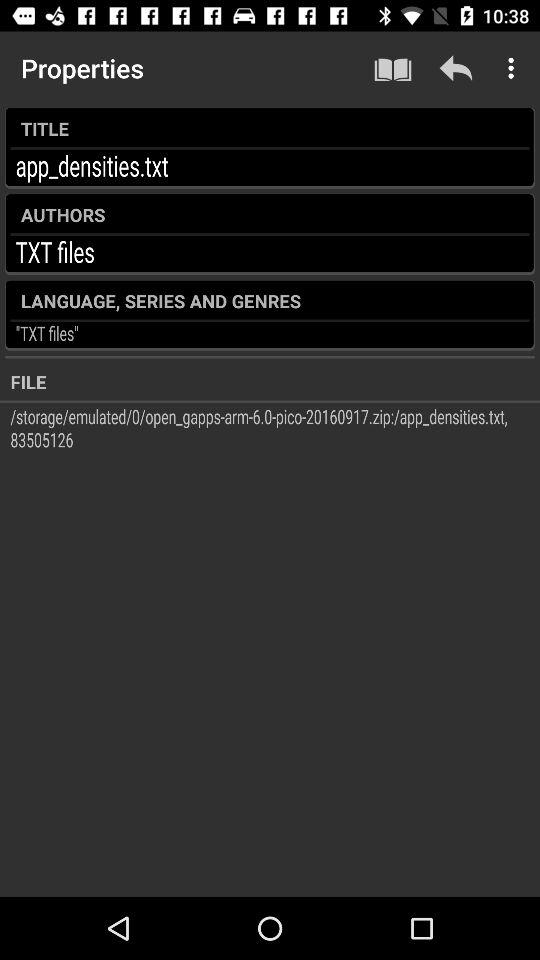What is the title? The title is "app_densities.txt". 